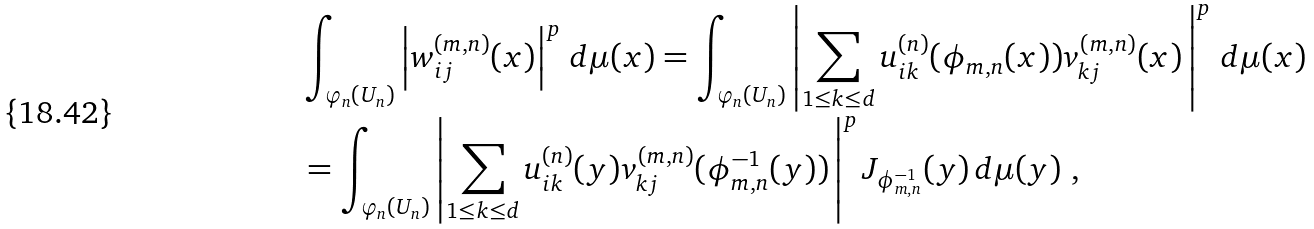Convert formula to latex. <formula><loc_0><loc_0><loc_500><loc_500>& \int _ { \varphi _ { n } ( U _ { n } ) } \left | w _ { i j } ^ { ( m , n ) } ( x ) \right | ^ { p } \, d \mu ( x ) = \int _ { \varphi _ { n } ( U _ { n } ) } \left | \sum _ { 1 \leq k \leq d } u _ { i k } ^ { ( n ) } ( \phi _ { m , n } ( x ) ) v _ { k j } ^ { ( m , n ) } ( x ) \, \right | ^ { p } \, d \mu ( x ) \\ & = \int _ { \varphi _ { n } ( U _ { n } ) } \left | \sum _ { 1 \leq k \leq d } u _ { i k } ^ { ( n ) } ( y ) v _ { k j } ^ { ( m , n ) } ( \phi _ { m , n } ^ { - 1 } ( y ) ) \, \right | ^ { p } J _ { \phi _ { m , n } ^ { - 1 } } ( y ) \, d \mu ( y ) \ ,</formula> 